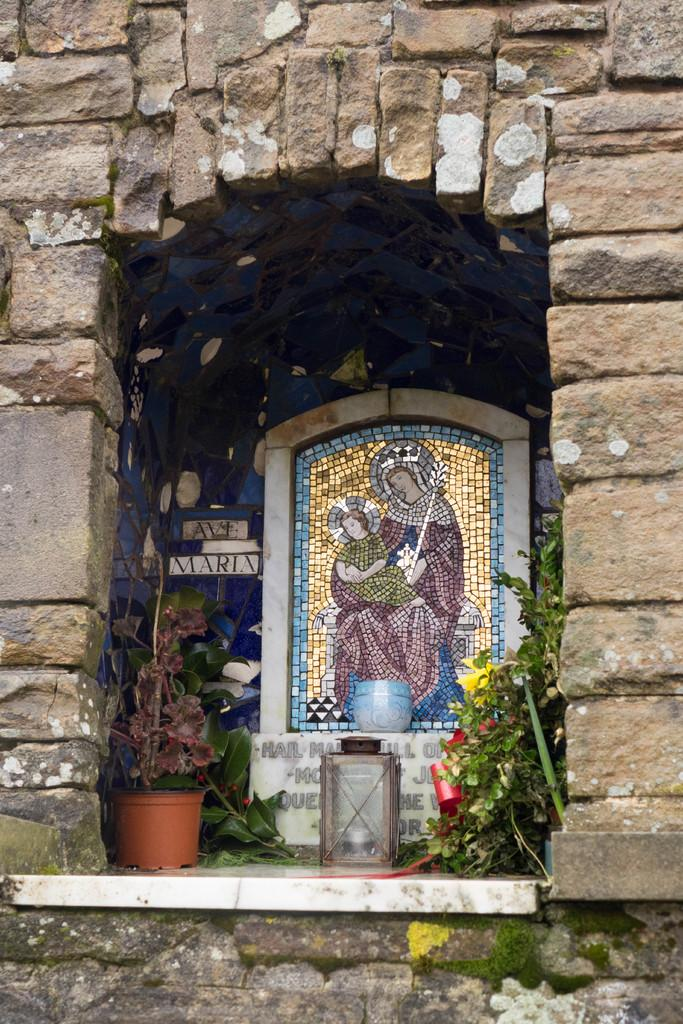What is depicted in the image involving a goddess and a child? There is a representation of a goddess with a child in the image. How is the representation created? The representation is made with pieces of tiles. What type of vegetation can be seen in the image? There are plants in the image. What object is used to hold plants in the image? There is a flower pot in the image. Where is the glass lantern located in the image? The glass lantern is mounted on a wall. What type of ice can be seen melting on the goddess's head in the image? There is no ice present in the image, and the goddess's head is not depicted as having ice on it. 